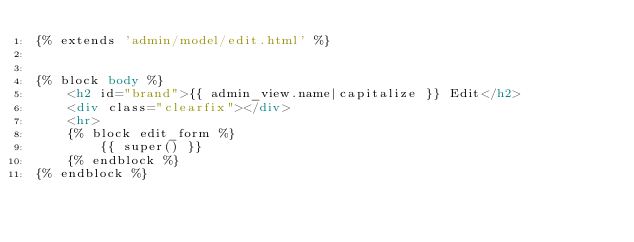<code> <loc_0><loc_0><loc_500><loc_500><_HTML_>{% extends 'admin/model/edit.html' %}


{% block body %}
    <h2 id="brand">{{ admin_view.name|capitalize }} Edit</h2>
    <div class="clearfix"></div>
    <hr>
    {% block edit_form %}
        {{ super() }}
    {% endblock %}
{% endblock %}</code> 